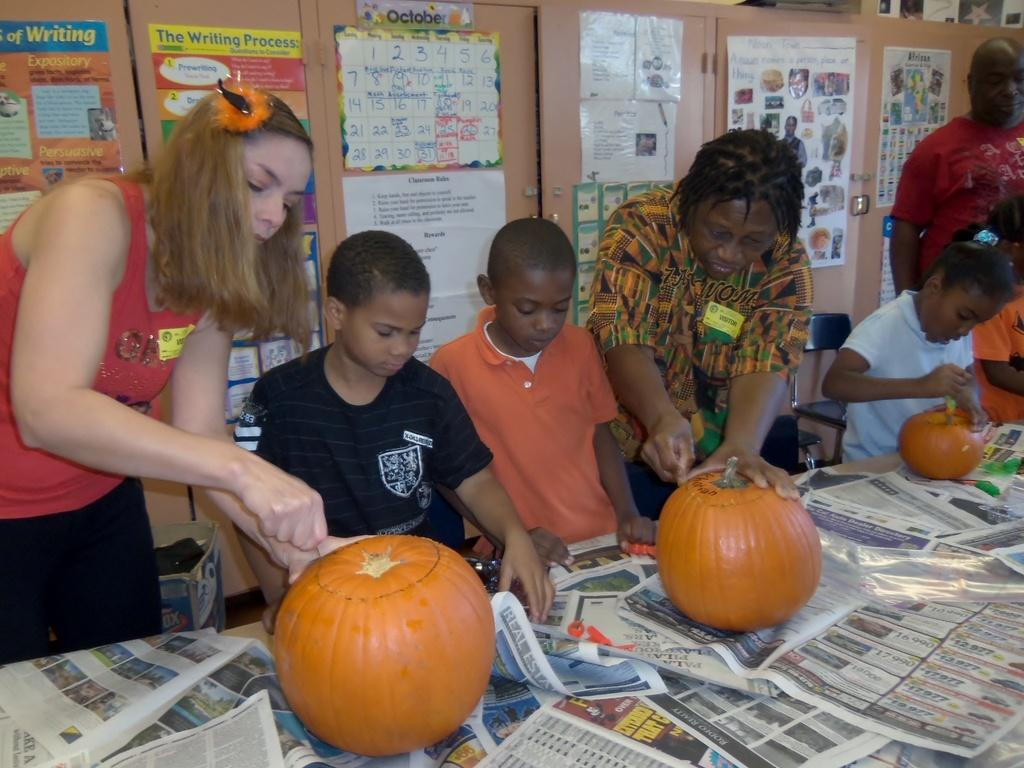How many people are in the image? There are persons in the image, but the exact number is not specified. What is the main piece of furniture in the image? There is a table in the image. What items can be seen on the table? Papers and pumpkins are on the table. What can be seen in the background of the image? There are posters and a door in the background of the image. What type of adjustment is being made to the person's hair in the image? There is no indication in the image that any adjustment is being made to anyone's hair. What is the nature of the love depicted in the image? There is no depiction of love in the image; it features persons, a table, papers, pumpkins, posters, and a door. 